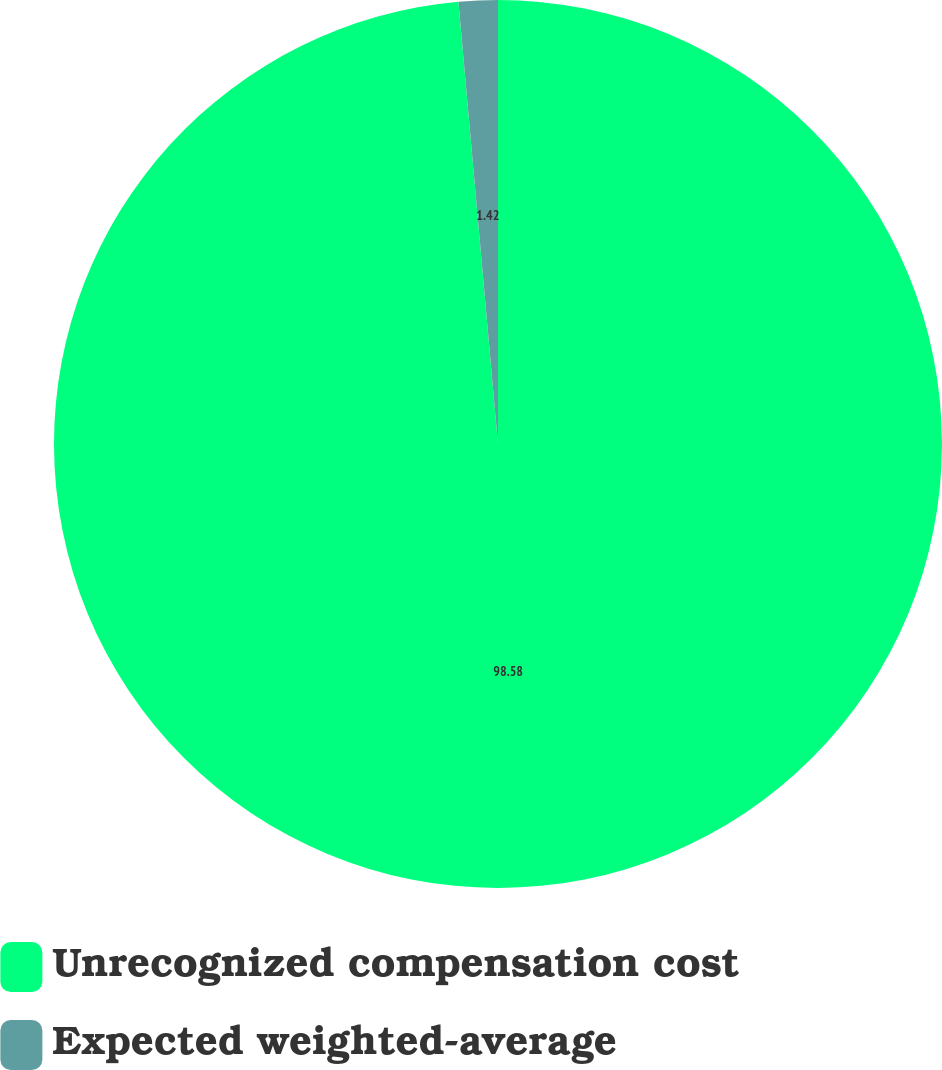Convert chart to OTSL. <chart><loc_0><loc_0><loc_500><loc_500><pie_chart><fcel>Unrecognized compensation cost<fcel>Expected weighted-average<nl><fcel>98.58%<fcel>1.42%<nl></chart> 